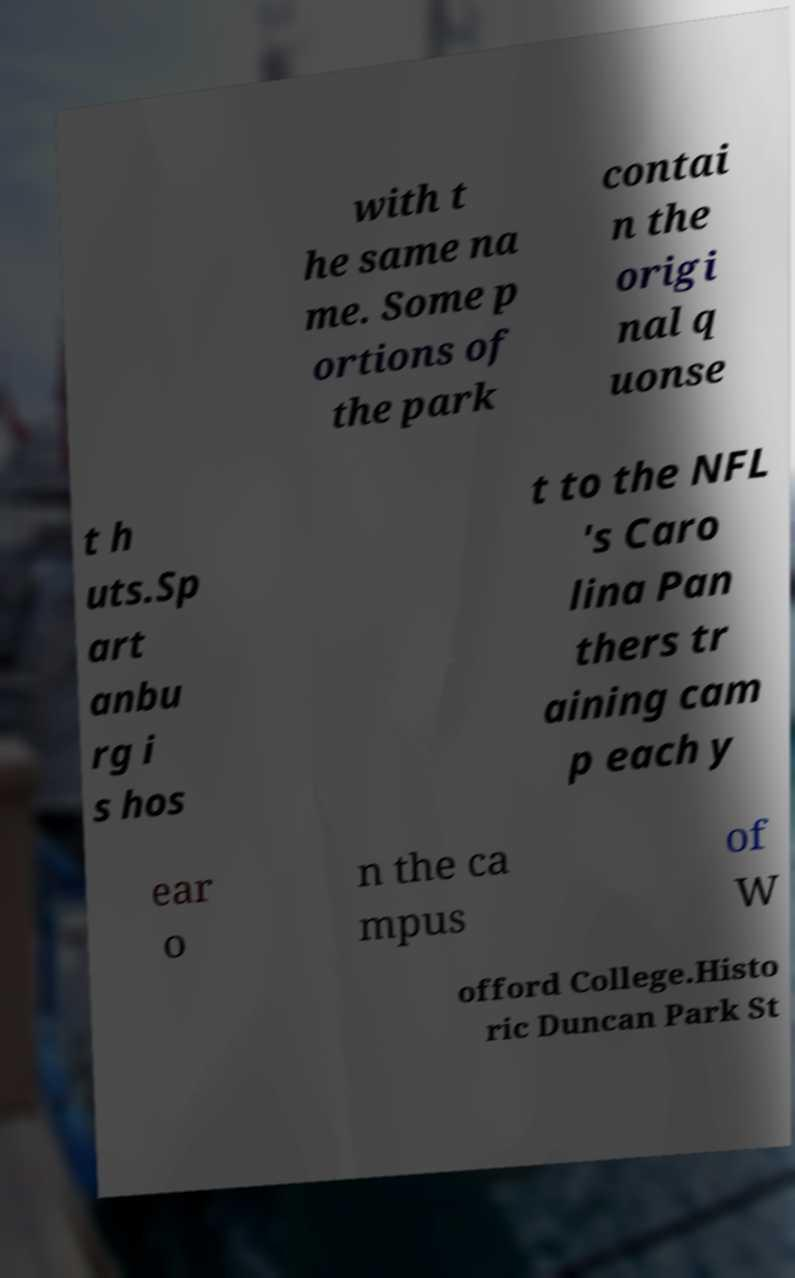Could you assist in decoding the text presented in this image and type it out clearly? with t he same na me. Some p ortions of the park contai n the origi nal q uonse t h uts.Sp art anbu rg i s hos t to the NFL 's Caro lina Pan thers tr aining cam p each y ear o n the ca mpus of W offord College.Histo ric Duncan Park St 